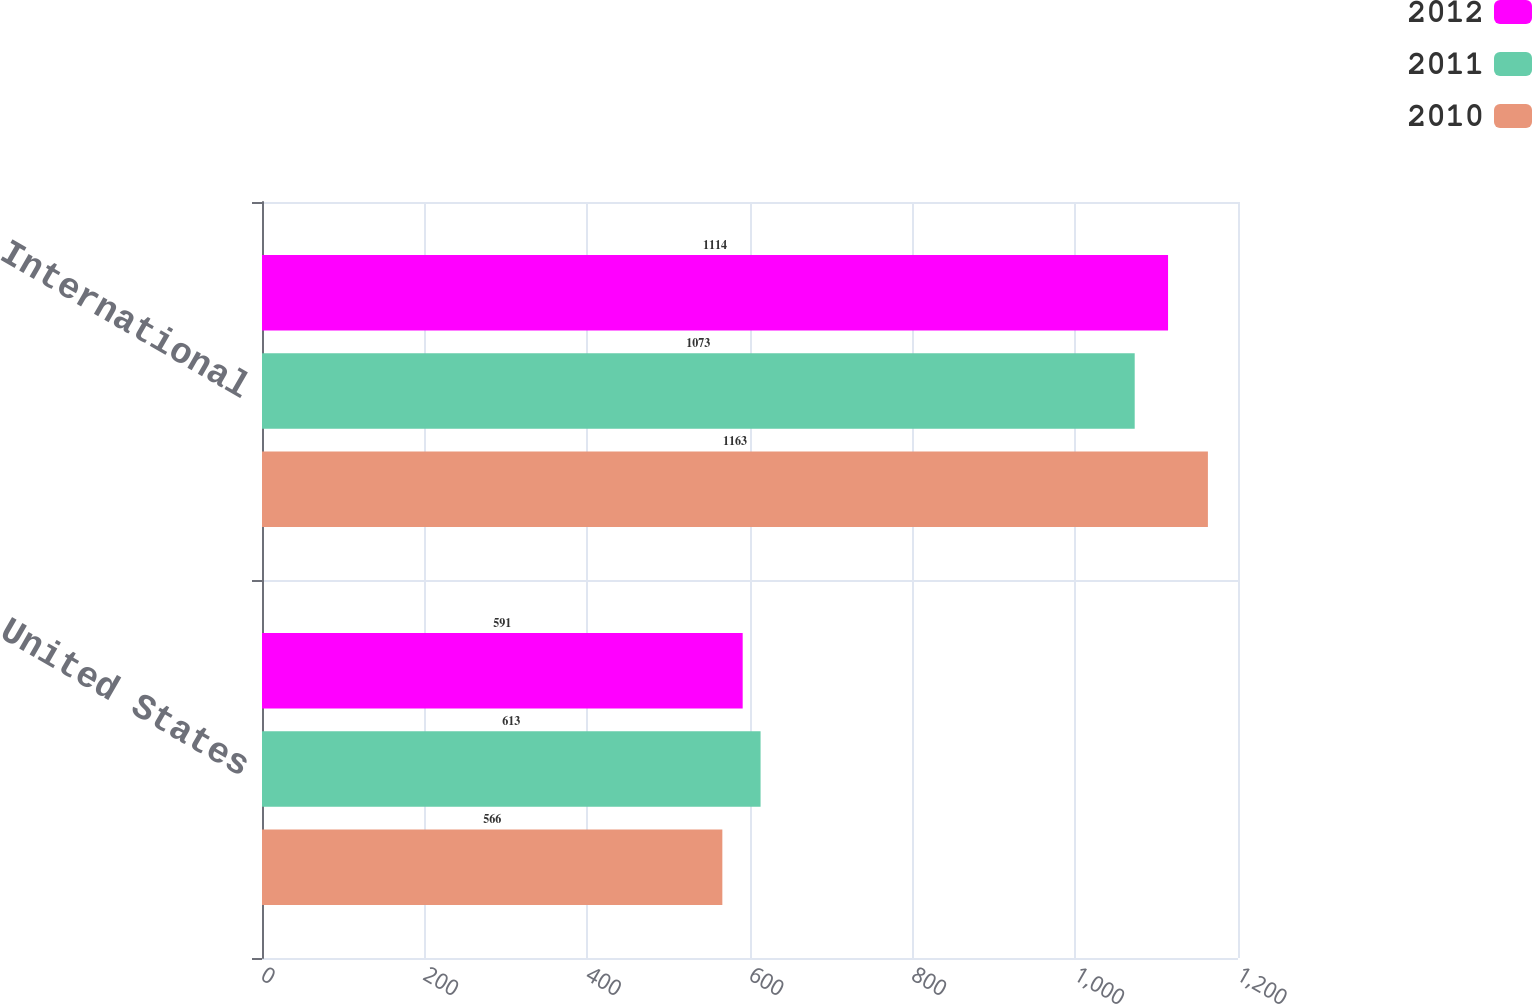Convert chart. <chart><loc_0><loc_0><loc_500><loc_500><stacked_bar_chart><ecel><fcel>United States<fcel>International<nl><fcel>2012<fcel>591<fcel>1114<nl><fcel>2011<fcel>613<fcel>1073<nl><fcel>2010<fcel>566<fcel>1163<nl></chart> 